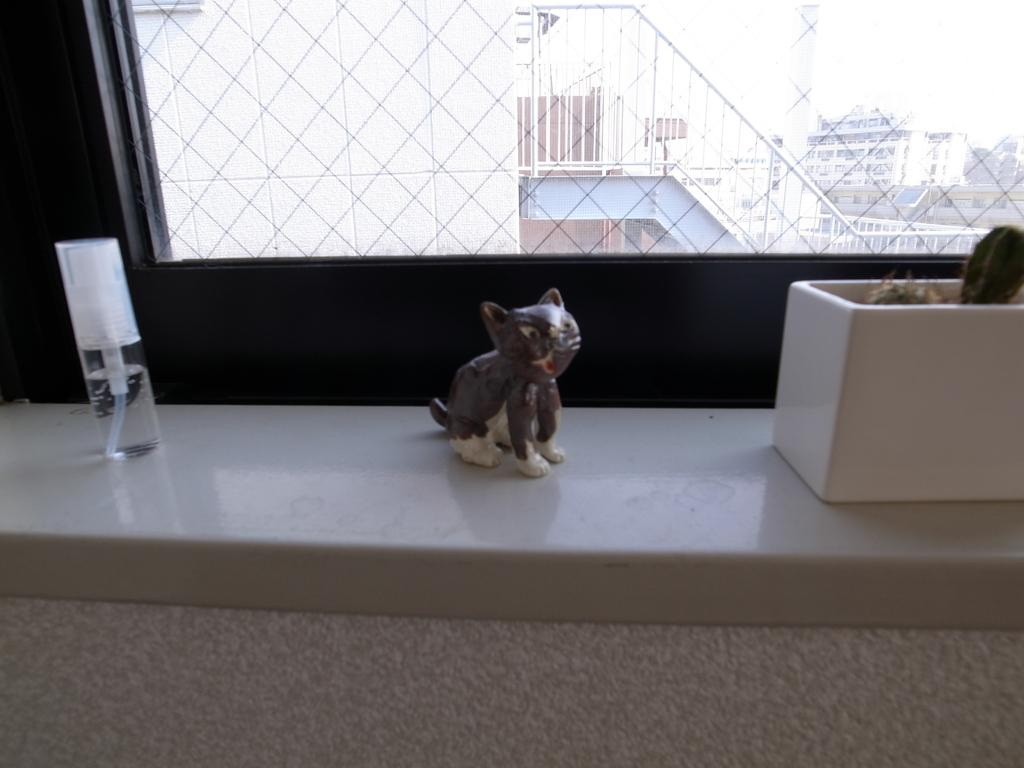What is the color of the surface in the image? The surface in the image is white. What objects can be seen on the white surface? There is a bottle, a statue, and a plant on the white surface. What is the purpose of the window in the image? The window allows for visibility of the buildings outside. What can be seen through the window? Buildings are visible through the window. Is there a pin crushing the plant in the image? No, there is no pin present in the image, and the plant is not being crushed. 